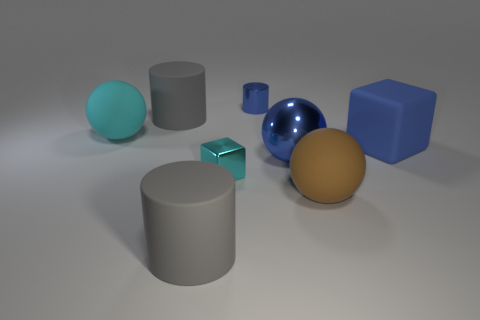Add 2 large metallic cubes. How many objects exist? 10 Subtract all cylinders. How many objects are left? 5 Add 6 blue matte blocks. How many blue matte blocks exist? 7 Subtract 1 blue balls. How many objects are left? 7 Subtract all gray matte cylinders. Subtract all big metal balls. How many objects are left? 5 Add 2 large matte cubes. How many large matte cubes are left? 3 